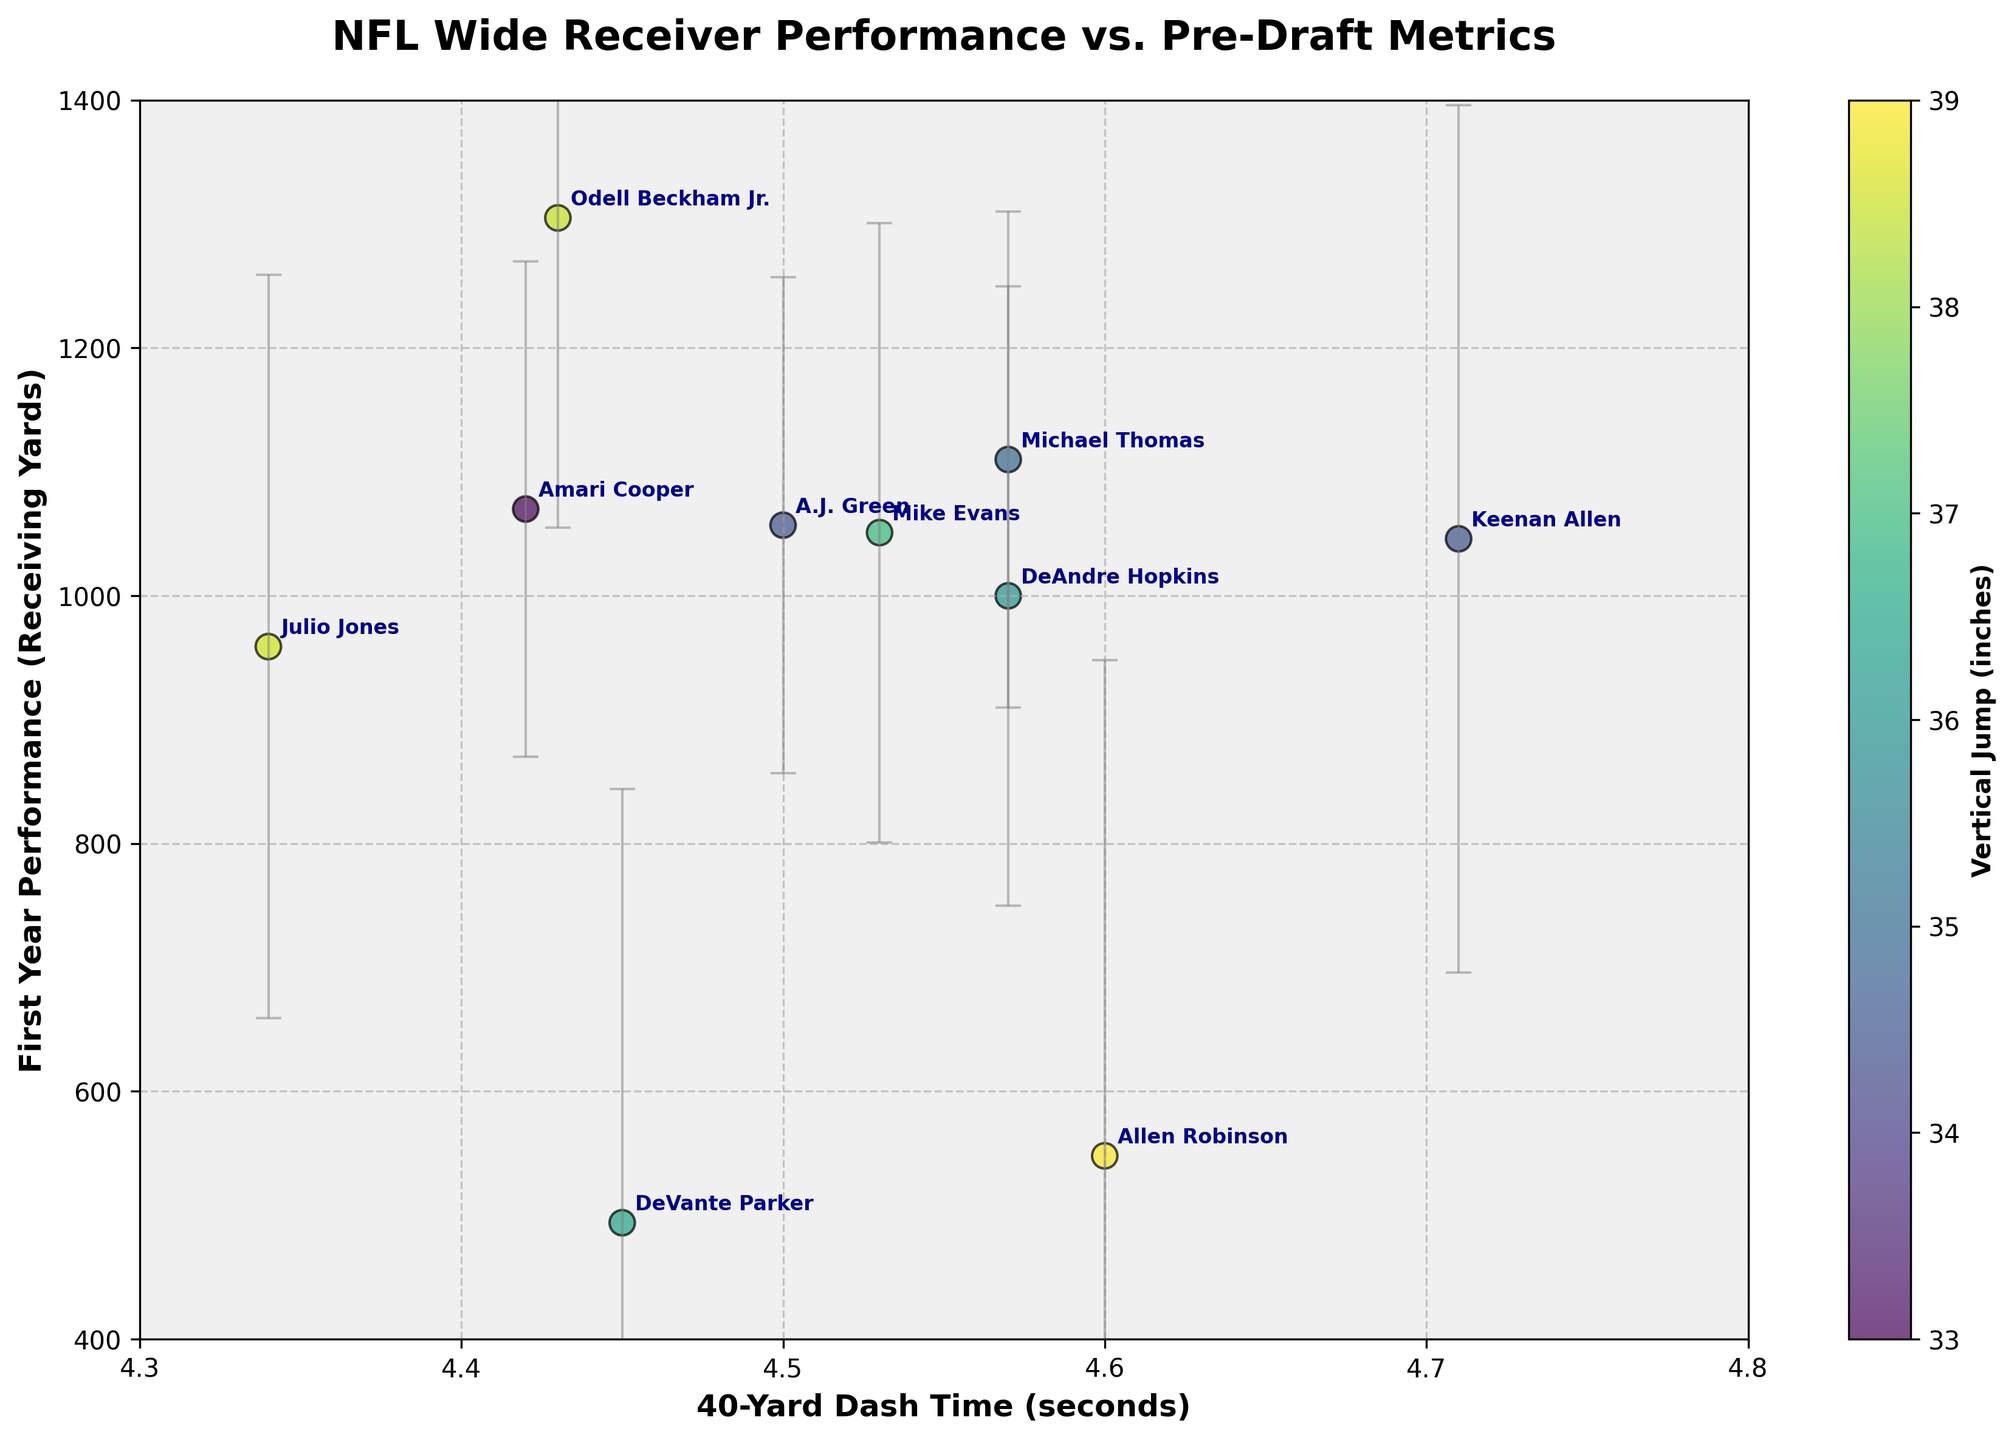What's the title of the figure? The title of the figure is found at the top and reads "NFL Wide Receiver Performance vs. Pre-Draft Metrics", indicating the relationship between pre-draft metrics and first-year performance.
Answer: NFL Wide Receiver Performance vs. Pre-Draft Metrics What metric is represented on the x-axis? The x-axis label reads "40-Yard Dash Time (seconds)", which measures players' speed during the 40-yard dash.
Answer: 40-Yard Dash Time (seconds) How many players are represented in the scatter plot? The scatter plot shows distinct data points, each representing a player. Counting the annotated names reveals 10 data points (players).
Answer: 10 Which player has the highest first-year performance? The y-axis measures first-year performance in receiving yards. The point highest on the y-axis is Odell Beckham Jr. with around 1305 yards.
Answer: Odell Beckham Jr What is the relationship between 40-yard dash time and first-year performance? The scatter plot shows negative correlation: players with faster 40-yard dash times (lower values on the x-axis) generally have higher first-year performances (higher values on the y-axis).
Answer: Negative correlation Which player has the highest vertical jump and what are his 40-yard dash time and first-year performance? By examining the color gradient in the scatter plot, Odell Beckham Jr. has the darkest shade, indicating the highest vertical jump at 38.5 inches. He also has a 40-yard dash time of 4.43 seconds and first-year performance of 1305 yards.
Answer: Odell Beckham Jr., 4.43 seconds, 1305 yards What is the average value of the scouting report variability for the players shown? Scouting report variability values: 5, 4, 5, 6, 7, 4, 8, 4, 7, 5. Sum = 55. There are 10 players, so the average is 55/10.
Answer: 5.5 Who has the highest error bar and what does it indicate? Allen Robinson has the highest error bar, indicated by his largest vertical error range. This suggests the greatest variability in scouting reports for him.
Answer: Allen Robinson What does the color of the data points represent? The color of the data points, according to the color bar, represents the vertical jump in inches. Darker colors indicate higher jumps.
Answer: Vertical jump Between Michael Thomas and Julio Jones, who had a better first-year performance and by how much? Michael Thomas's first-year performance is around 1110 yards, and Julio Jones's is 959 yards. Subtracting these values shows Thomas performed better by 151 yards.
Answer: Michael Thomas by 151 yards 